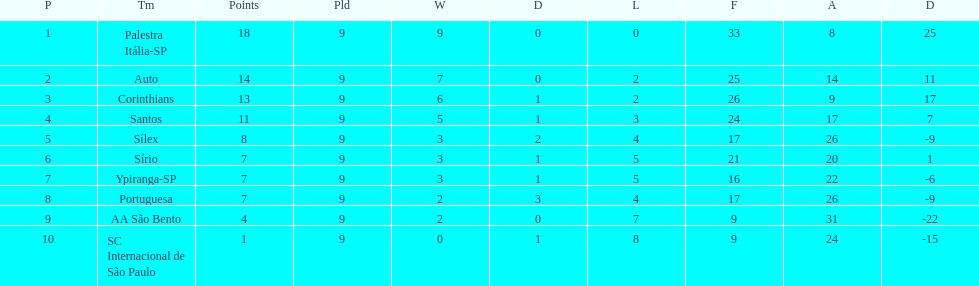How many games did each team play? 9, 9, 9, 9, 9, 9, 9, 9, 9, 9. Did any team score 13 points in the total games they played? 13. What is the name of that team? Corinthians. 